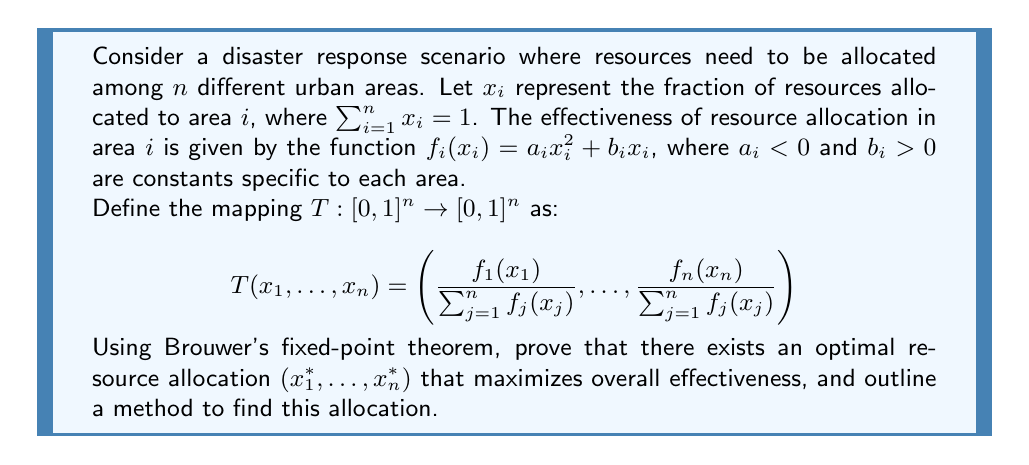Provide a solution to this math problem. To solve this problem, we'll follow these steps:

1) First, let's verify that Brouwer's fixed-point theorem applies to our mapping $T$:
   - $T$ maps $[0,1]^n$ to itself, as each component is a ratio of non-negative numbers and their sum is 1.
   - $T$ is continuous, as it's composed of continuous functions.
   - $[0,1]^n$ is a compact, convex set in $\mathbb{R}^n$.

2) Since the conditions are met, Brouwer's theorem guarantees the existence of a fixed point $x^* = (x_1^*, \ldots, x_n^*)$ such that $T(x^*) = x^*$.

3) This fixed point satisfies:

   $$x_i^* = \frac{f_i(x_i^*)}{\sum_{j=1}^n f_j(x_j^*)} \text{ for all } i$$

4) The fixed point $x^*$ represents an optimal allocation because:
   - If any $x_i$ were to increase, the corresponding $f_i(x_i)$ would increase less than proportionally (due to $a_i < 0$).
   - This would make the ratio $\frac{f_i(x_i)}{\sum_{j=1}^n f_j(x_j)}$ smaller, pushing $x_i$ back down.

5) To find this allocation, we can use an iterative method:
   - Start with an initial guess $x^{(0)} = (\frac{1}{n}, \ldots, \frac{1}{n})$.
   - Repeatedly apply $T$ to get $x^{(k+1)} = T(x^{(k)})$.
   - Continue until $\|x^{(k+1)} - x^{(k)}\| < \epsilon$ for some small $\epsilon$.

6) This method is guaranteed to converge to the fixed point due to the contraction mapping principle, as $T$ is a contraction mapping on $[0,1]^n$ with respect to an appropriate metric.
Answer: Optimal allocation exists at fixed point of $T$; find via iteration $x^{(k+1)} = T(x^{(k)})$. 